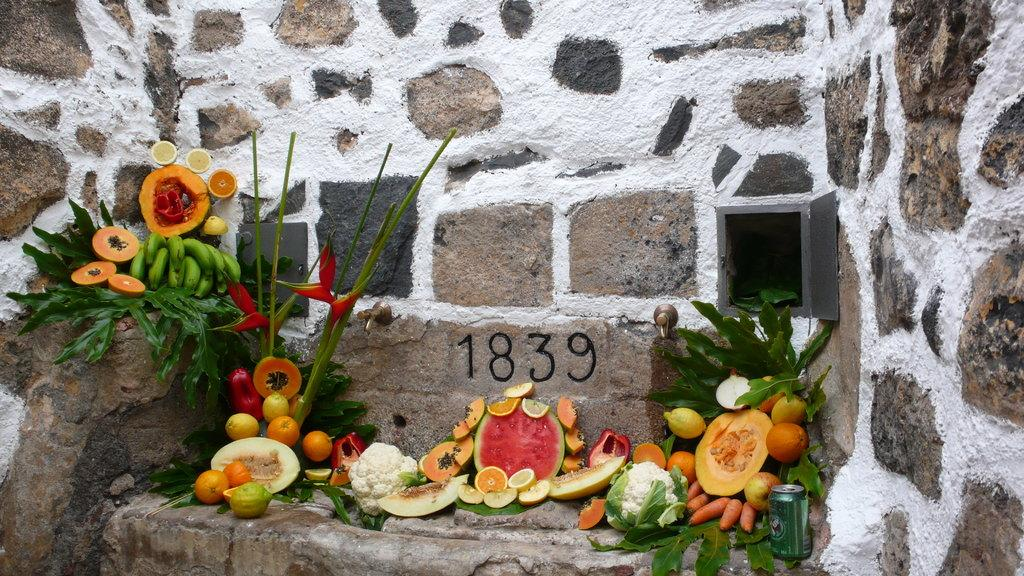What types of food are in the center of the image? There are fruits and vegetables in the center of the image. What other object can be seen in the image? There is a tin in the image. What is visible in the background of the image? There is a wall in the background of the image. How much value does the muscle have in the image? There is no muscle present in the image, so it is not possible to determine its value. 